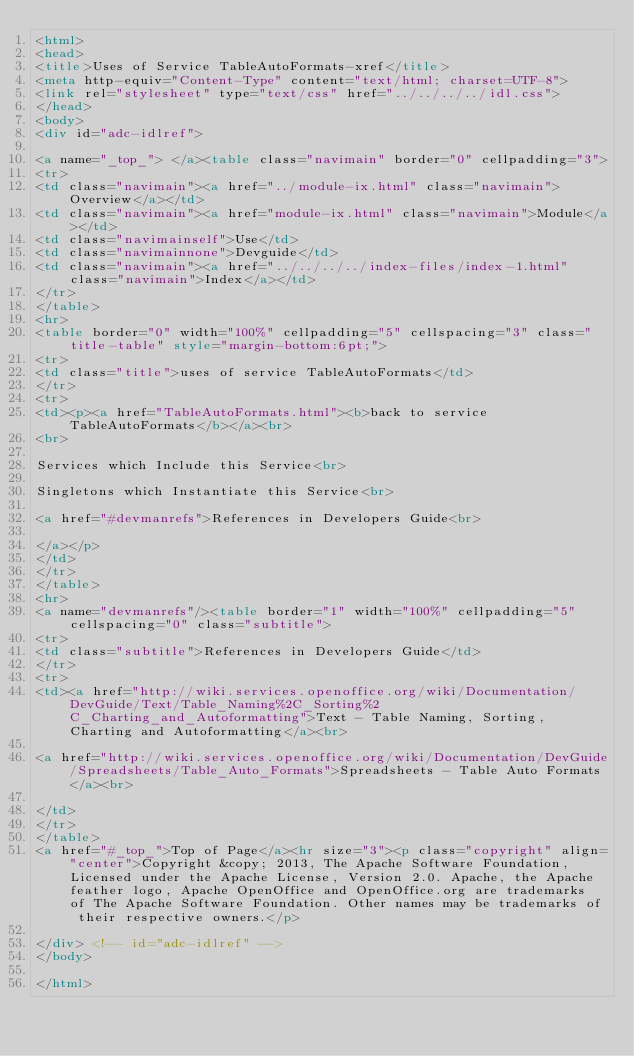Convert code to text. <code><loc_0><loc_0><loc_500><loc_500><_HTML_><html>
<head>
<title>Uses of Service TableAutoFormats-xref</title>
<meta http-equiv="Content-Type" content="text/html; charset=UTF-8">
<link rel="stylesheet" type="text/css" href="../../../../idl.css">
</head>
<body>
<div id="adc-idlref">

<a name="_top_"> </a><table class="navimain" border="0" cellpadding="3">
<tr>
<td class="navimain"><a href="../module-ix.html" class="navimain">Overview</a></td>
<td class="navimain"><a href="module-ix.html" class="navimain">Module</a></td>
<td class="navimainself">Use</td>
<td class="navimainnone">Devguide</td>
<td class="navimain"><a href="../../../../index-files/index-1.html" class="navimain">Index</a></td>
</tr>
</table>
<hr>
<table border="0" width="100%" cellpadding="5" cellspacing="3" class="title-table" style="margin-bottom:6pt;">
<tr>
<td class="title">uses of service TableAutoFormats</td>
</tr>
<tr>
<td><p><a href="TableAutoFormats.html"><b>back to service TableAutoFormats</b></a><br>
<br>

Services which Include this Service<br>

Singletons which Instantiate this Service<br>

<a href="#devmanrefs">References in Developers Guide<br>

</a></p>
</td>
</tr>
</table>
<hr>
<a name="devmanrefs"/><table border="1" width="100%" cellpadding="5" cellspacing="0" class="subtitle">
<tr>
<td class="subtitle">References in Developers Guide</td>
</tr>
<tr>
<td><a href="http://wiki.services.openoffice.org/wiki/Documentation/DevGuide/Text/Table_Naming%2C_Sorting%2C_Charting_and_Autoformatting">Text - Table Naming, Sorting, Charting and Autoformatting</a><br>

<a href="http://wiki.services.openoffice.org/wiki/Documentation/DevGuide/Spreadsheets/Table_Auto_Formats">Spreadsheets - Table Auto Formats</a><br>

</td>
</tr>
</table>
<a href="#_top_">Top of Page</a><hr size="3"><p class="copyright" align="center">Copyright &copy; 2013, The Apache Software Foundation, Licensed under the Apache License, Version 2.0. Apache, the Apache feather logo, Apache OpenOffice and OpenOffice.org are trademarks of The Apache Software Foundation. Other names may be trademarks of their respective owners.</p>

</div> <!-- id="adc-idlref" -->
</body>

</html>
</code> 